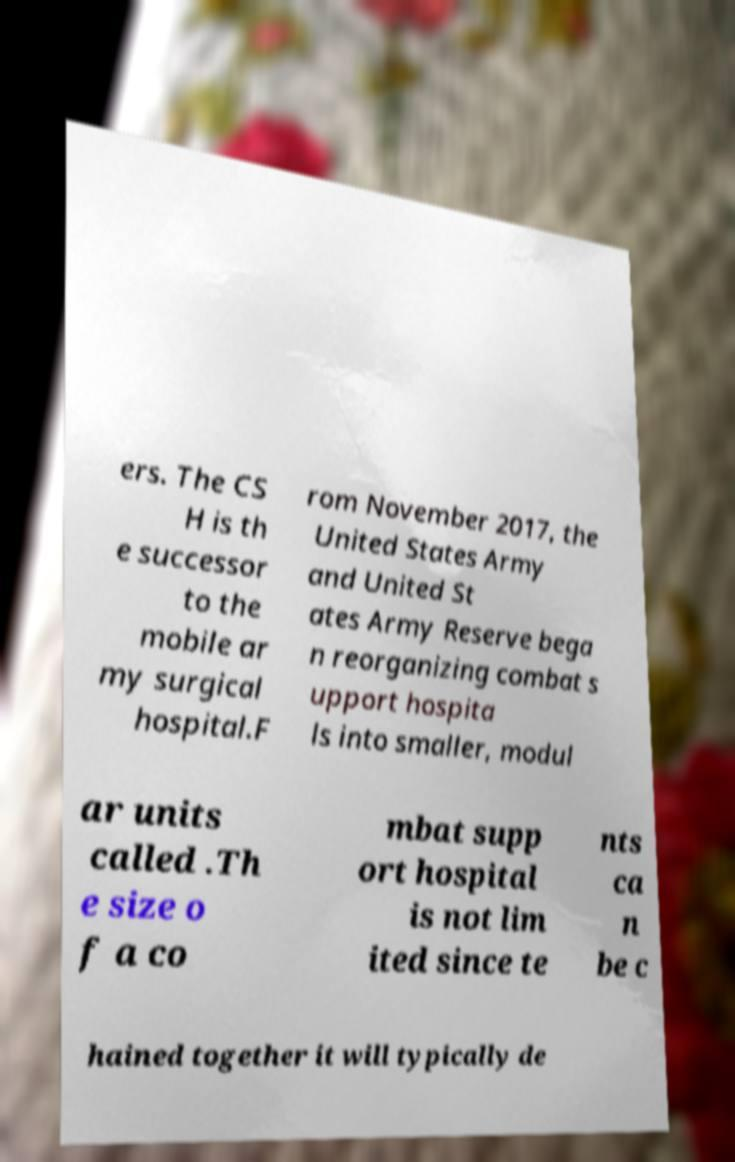There's text embedded in this image that I need extracted. Can you transcribe it verbatim? ers. The CS H is th e successor to the mobile ar my surgical hospital.F rom November 2017, the United States Army and United St ates Army Reserve bega n reorganizing combat s upport hospita ls into smaller, modul ar units called .Th e size o f a co mbat supp ort hospital is not lim ited since te nts ca n be c hained together it will typically de 